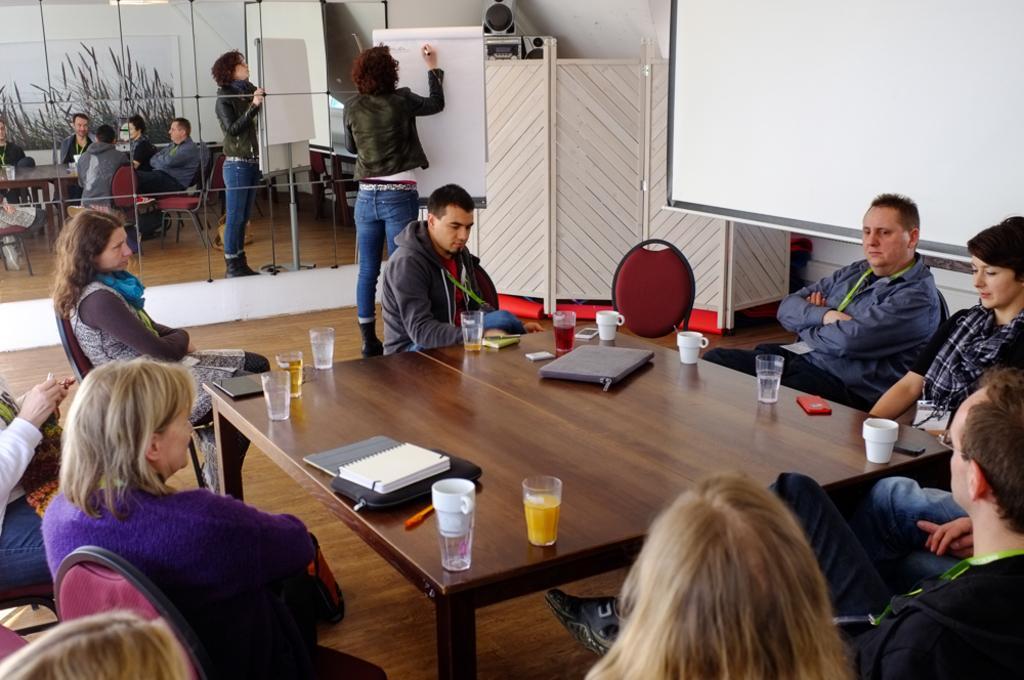Can you describe this image briefly? There are some people sitting in the chairs around the table on which some files, glasses and cups were placed. In the background there is a woman writing something on the board. She is standing. We can observe a projector display screen and a mirrors here. 